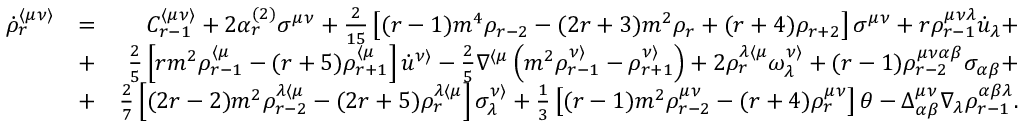Convert formula to latex. <formula><loc_0><loc_0><loc_500><loc_500>\begin{array} { r l r } { \dot { \rho } _ { r } ^ { \langle \mu \nu \rangle } } & { = } & { C _ { r - 1 } ^ { \langle \mu \nu \rangle } + 2 \alpha _ { r } ^ { ( 2 ) } \sigma ^ { \mu \nu } + \frac { 2 } { 1 5 } \left [ ( r - 1 ) m ^ { 4 } \rho _ { r - 2 } - ( 2 r + 3 ) m ^ { 2 } \rho _ { r } + ( r + 4 ) \rho _ { r + 2 } \right ] \sigma ^ { \mu \nu } + r \rho _ { r - 1 } ^ { \mu \nu \lambda } \dot { u } _ { \lambda } + } \\ & { + } & { \frac { 2 } { 5 } \left [ r m ^ { 2 } \rho _ { r - 1 } ^ { \langle \mu } - ( r + 5 ) \rho _ { r + 1 } ^ { \langle \mu } \right ] \dot { u } ^ { \nu \rangle } - \frac { 2 } { 5 } \nabla ^ { \langle \mu } \left ( m ^ { 2 } \rho _ { r - 1 } ^ { \nu \rangle } - \rho _ { r + 1 } ^ { \nu \rangle } \right ) + 2 \rho _ { r } ^ { \lambda \langle \mu } \omega ^ { \nu \rangle } _ { \lambda } + ( r - 1 ) \rho _ { r - 2 } ^ { \mu \nu \alpha \beta } \sigma _ { \alpha \beta } + } \\ & { + } & { \frac { 2 } { 7 } \left [ ( 2 r - 2 ) m ^ { 2 } \rho _ { r - 2 } ^ { \lambda \langle \mu } - ( 2 r + 5 ) \rho _ { r } ^ { \lambda \langle \mu } \right ] \sigma _ { \lambda } ^ { \nu \rangle } + \frac { 1 } { 3 } \left [ ( r - 1 ) m ^ { 2 } \rho _ { r - 2 } ^ { \mu \nu } - ( r + 4 ) \rho _ { r } ^ { \mu \nu } \right ] \theta - \Delta _ { \alpha \beta } ^ { \mu \nu } \nabla _ { \lambda } \rho _ { r - 1 } ^ { \alpha \beta \lambda } . } \end{array}</formula> 